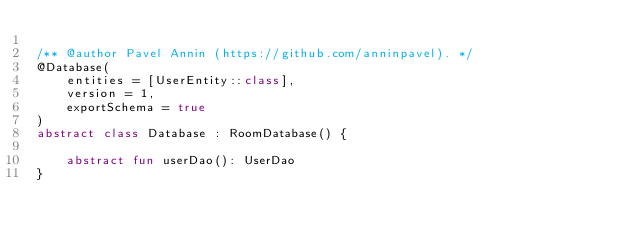Convert code to text. <code><loc_0><loc_0><loc_500><loc_500><_Kotlin_>
/** @author Pavel Annin (https://github.com/anninpavel). */
@Database(
    entities = [UserEntity::class],
    version = 1,
    exportSchema = true
)
abstract class Database : RoomDatabase() {

    abstract fun userDao(): UserDao
}</code> 